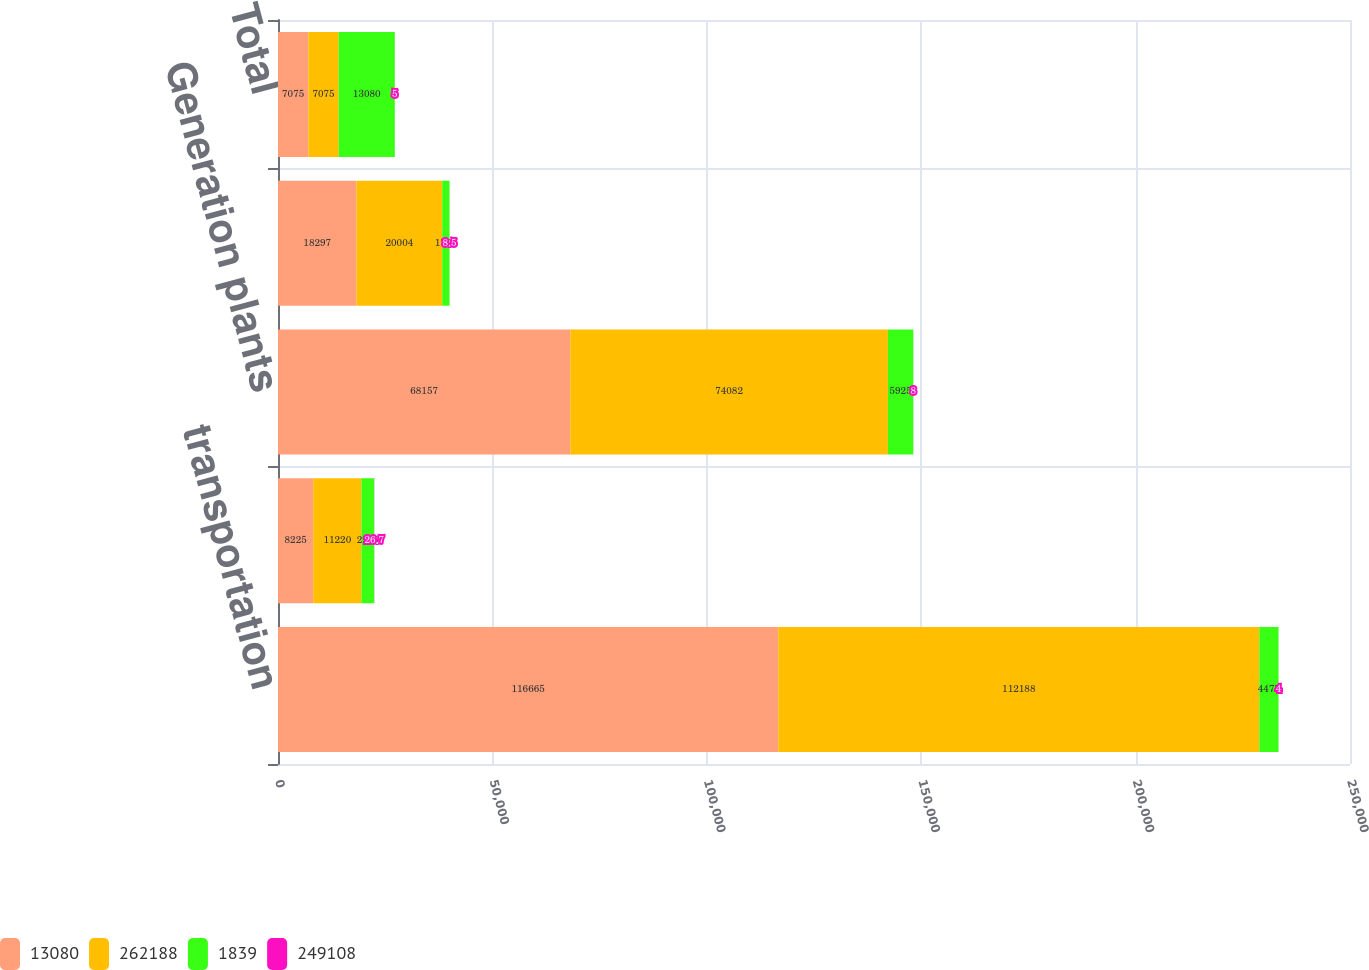<chart> <loc_0><loc_0><loc_500><loc_500><stacked_bar_chart><ecel><fcel>transportation<fcel>Interruptible sales<fcel>Generation plants<fcel>Other<fcel>Total<nl><fcel>13080<fcel>116665<fcel>8225<fcel>68157<fcel>18297<fcel>7075<nl><fcel>262188<fcel>112188<fcel>11220<fcel>74082<fcel>20004<fcel>7075<nl><fcel>1839<fcel>4477<fcel>2995<fcel>5925<fcel>1707<fcel>13080<nl><fcel>249108<fcel>4<fcel>26.7<fcel>8<fcel>8.5<fcel>5<nl></chart> 